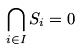Convert formula to latex. <formula><loc_0><loc_0><loc_500><loc_500>\bigcap _ { i \in I } S _ { i } = 0</formula> 